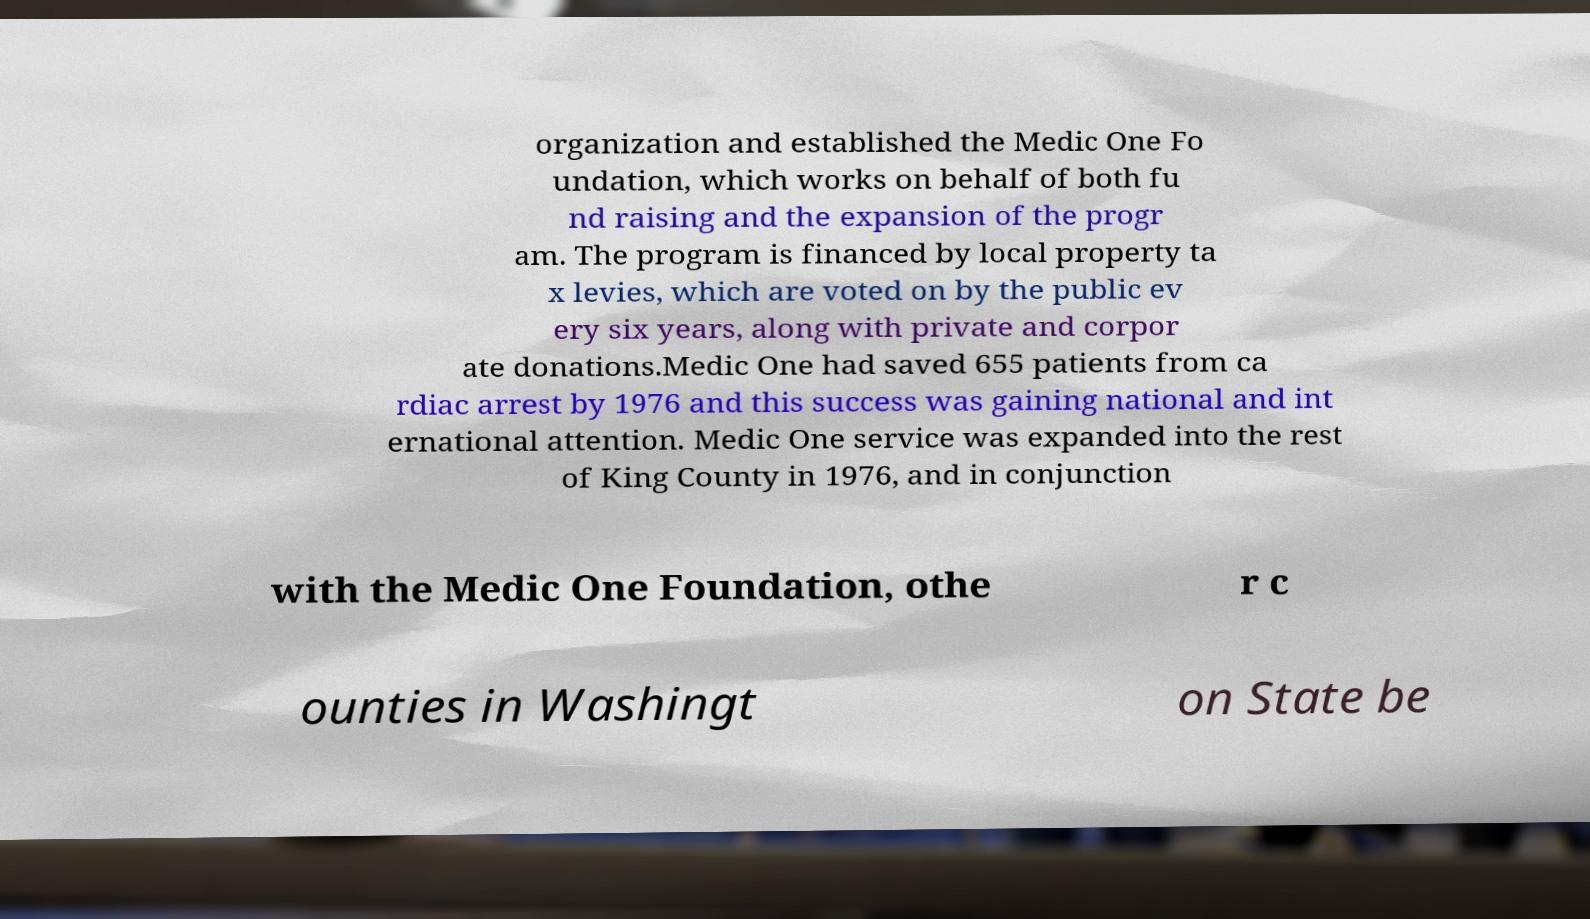Please read and relay the text visible in this image. What does it say? organization and established the Medic One Fo undation, which works on behalf of both fu nd raising and the expansion of the progr am. The program is financed by local property ta x levies, which are voted on by the public ev ery six years, along with private and corpor ate donations.Medic One had saved 655 patients from ca rdiac arrest by 1976 and this success was gaining national and int ernational attention. Medic One service was expanded into the rest of King County in 1976, and in conjunction with the Medic One Foundation, othe r c ounties in Washingt on State be 